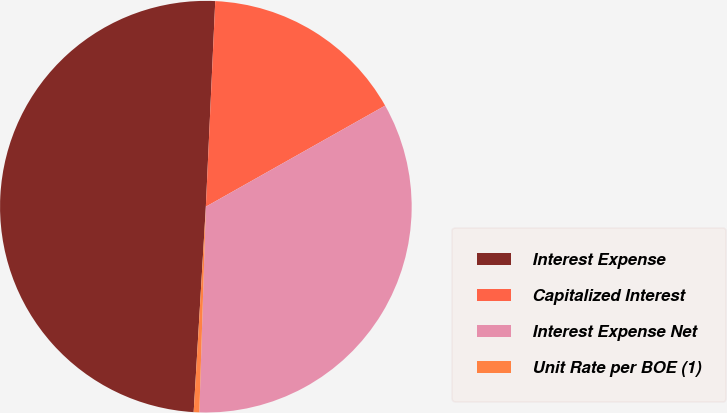Convert chart. <chart><loc_0><loc_0><loc_500><loc_500><pie_chart><fcel>Interest Expense<fcel>Capitalized Interest<fcel>Interest Expense Net<fcel>Unit Rate per BOE (1)<nl><fcel>49.78%<fcel>16.1%<fcel>33.67%<fcel>0.44%<nl></chart> 